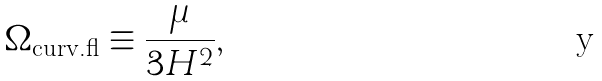Convert formula to latex. <formula><loc_0><loc_0><loc_500><loc_500>\Omega _ { \text {curv.fl} } \equiv \frac { \mu } { 3 H ^ { 2 } } ,</formula> 